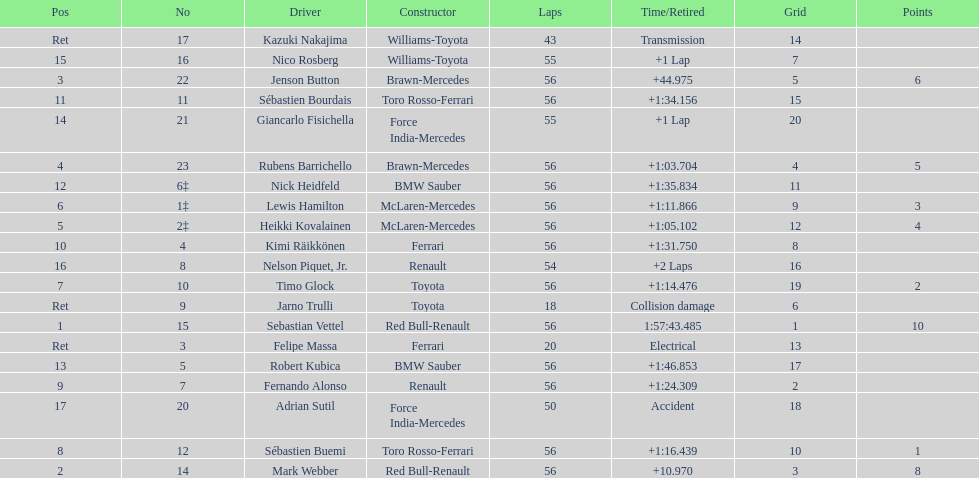How many drivers did not finish 56 laps? 7. 